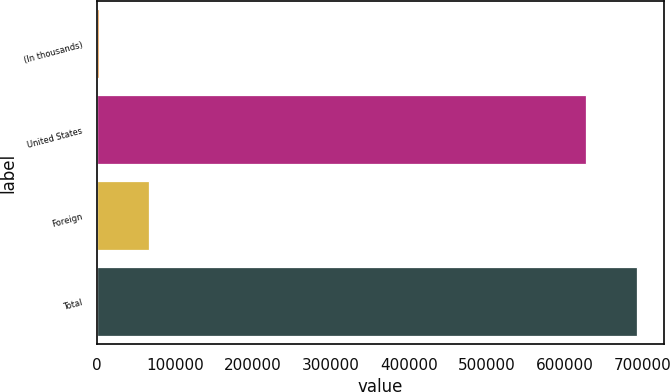Convert chart. <chart><loc_0><loc_0><loc_500><loc_500><bar_chart><fcel>(In thousands)<fcel>United States<fcel>Foreign<fcel>Total<nl><fcel>2009<fcel>627600<fcel>67151.2<fcel>692742<nl></chart> 